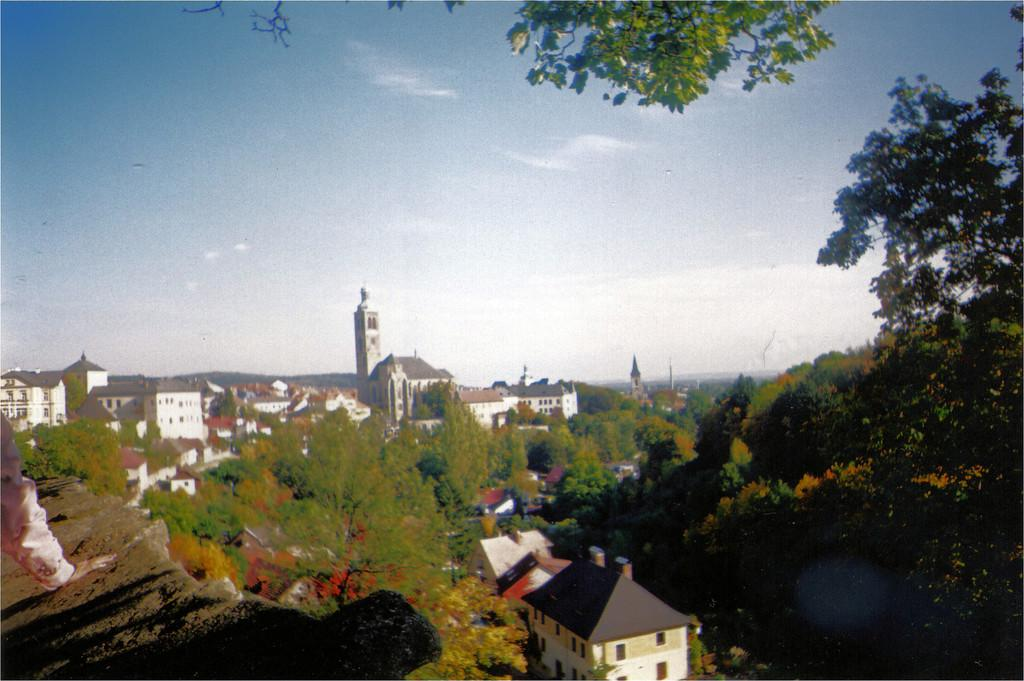What type of natural elements can be seen in the image? There are trees in the image. What type of man-made structures are present in the image? There are buildings in the image. Where is a person's hand located in the image? A person's hand is visible on the left side of the image. What can be seen in the background of the image? There are clouds and the sky visible in the background of the image. What type of card is being held by the person in the image? There is no card present in the image; only a person's hand is visible on the left side. How does the image demonstrate respect for the environment? The image does not demonstrate respect for the environment, as it only shows trees, buildings, and a person's hand. 